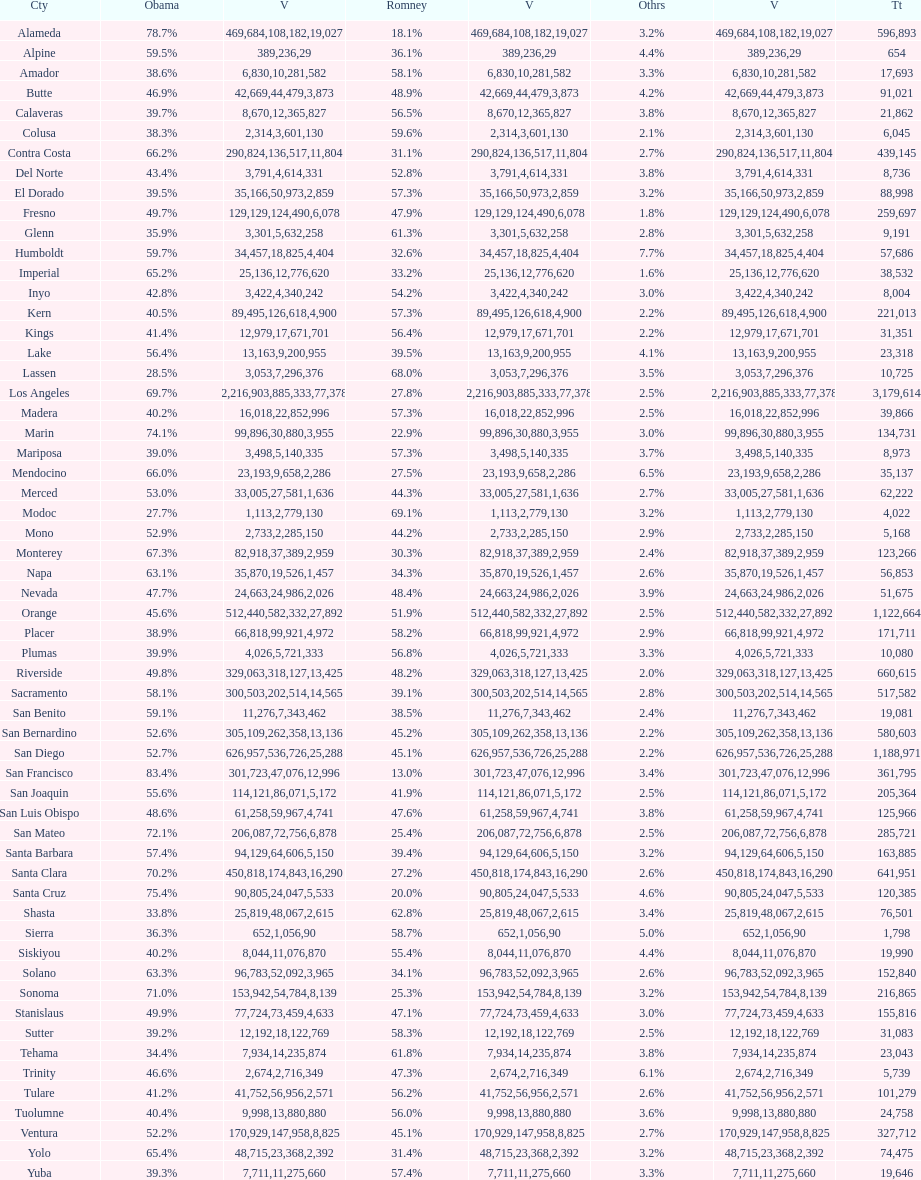What county is just before del norte on the list? Contra Costa. 